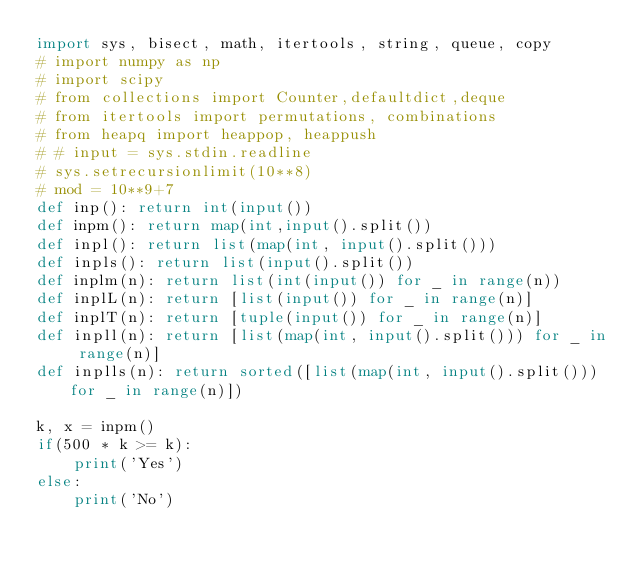Convert code to text. <code><loc_0><loc_0><loc_500><loc_500><_Python_>import sys, bisect, math, itertools, string, queue, copy
# import numpy as np
# import scipy
# from collections import Counter,defaultdict,deque
# from itertools import permutations, combinations
# from heapq import heappop, heappush
# # input = sys.stdin.readline
# sys.setrecursionlimit(10**8)
# mod = 10**9+7
def inp(): return int(input())
def inpm(): return map(int,input().split())
def inpl(): return list(map(int, input().split()))
def inpls(): return list(input().split())
def inplm(n): return list(int(input()) for _ in range(n))
def inplL(n): return [list(input()) for _ in range(n)]
def inplT(n): return [tuple(input()) for _ in range(n)]
def inpll(n): return [list(map(int, input().split())) for _ in range(n)]
def inplls(n): return sorted([list(map(int, input().split())) for _ in range(n)])

k, x = inpm()
if(500 * k >= k):
    print('Yes')
else:
    print('No')
</code> 